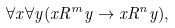<formula> <loc_0><loc_0><loc_500><loc_500>\forall x \forall y ( x R ^ { m } y \rightarrow x R ^ { n } y ) ,</formula> 